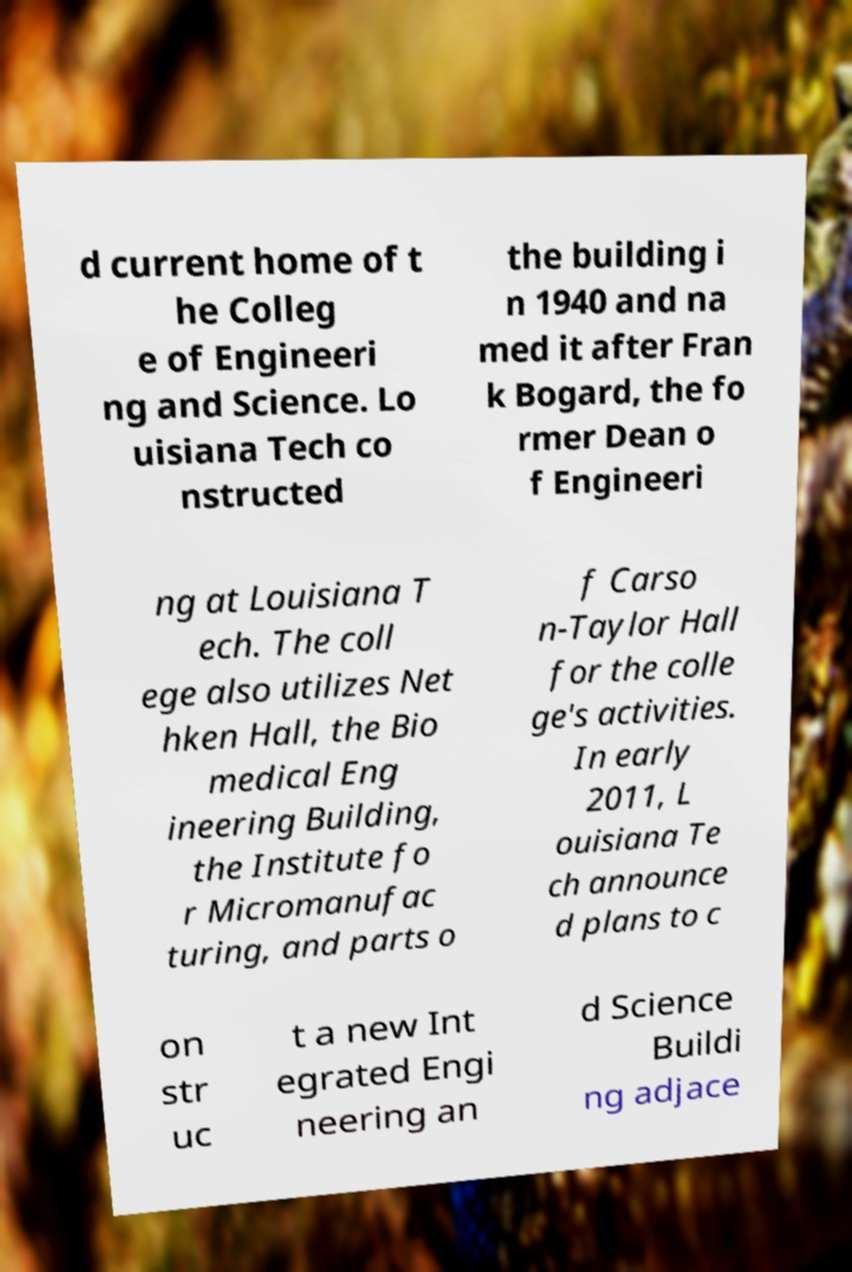For documentation purposes, I need the text within this image transcribed. Could you provide that? d current home of t he Colleg e of Engineeri ng and Science. Lo uisiana Tech co nstructed the building i n 1940 and na med it after Fran k Bogard, the fo rmer Dean o f Engineeri ng at Louisiana T ech. The coll ege also utilizes Net hken Hall, the Bio medical Eng ineering Building, the Institute fo r Micromanufac turing, and parts o f Carso n-Taylor Hall for the colle ge's activities. In early 2011, L ouisiana Te ch announce d plans to c on str uc t a new Int egrated Engi neering an d Science Buildi ng adjace 